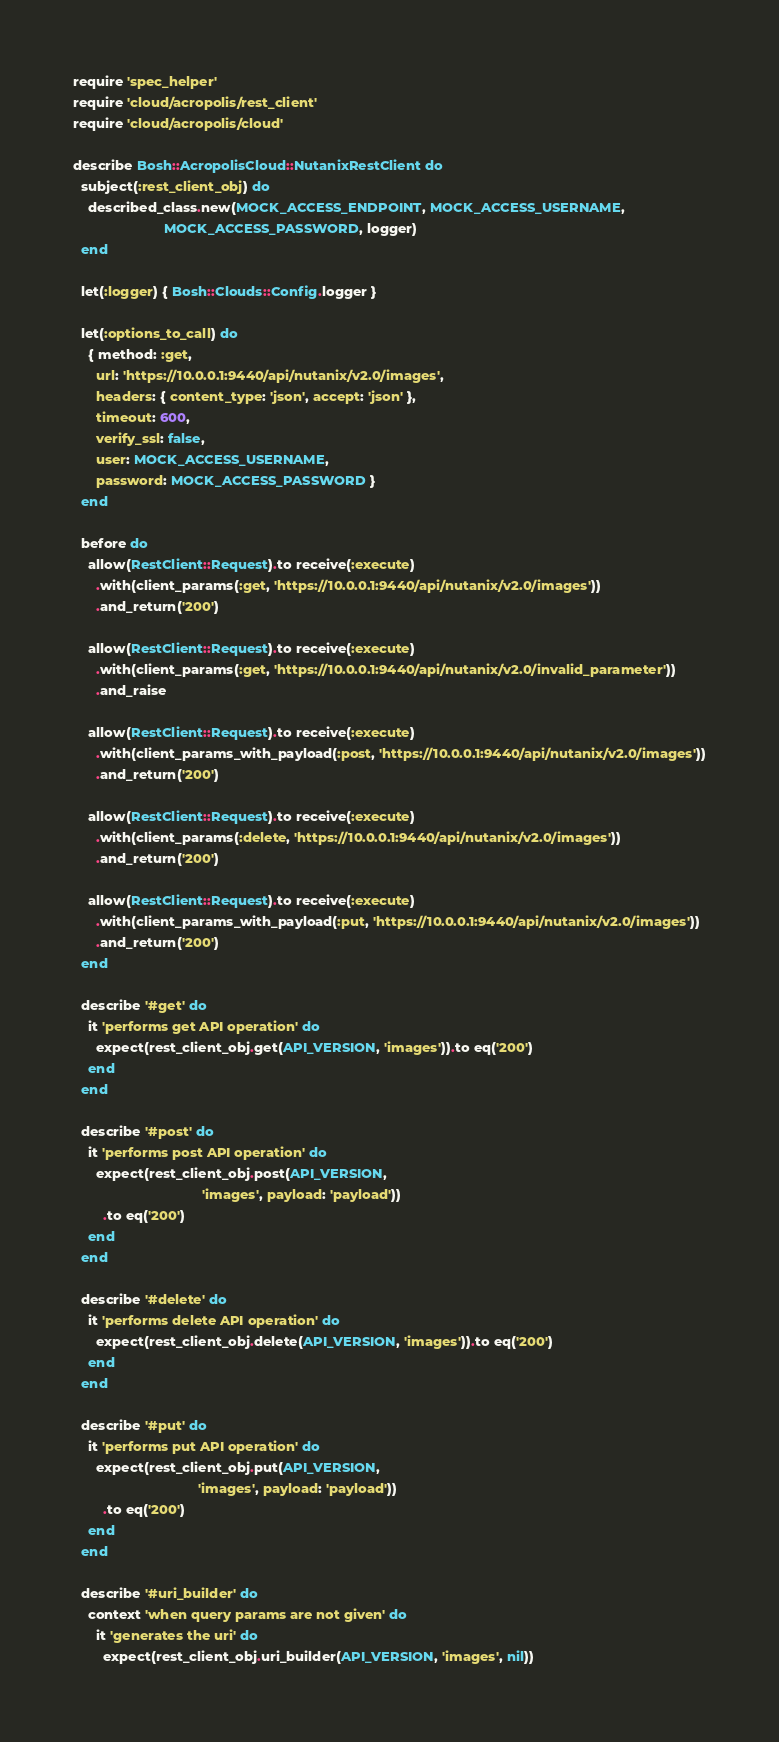<code> <loc_0><loc_0><loc_500><loc_500><_Ruby_>require 'spec_helper'
require 'cloud/acropolis/rest_client'
require 'cloud/acropolis/cloud'

describe Bosh::AcropolisCloud::NutanixRestClient do
  subject(:rest_client_obj) do
    described_class.new(MOCK_ACCESS_ENDPOINT, MOCK_ACCESS_USERNAME,
                        MOCK_ACCESS_PASSWORD, logger)
  end

  let(:logger) { Bosh::Clouds::Config.logger }

  let(:options_to_call) do
    { method: :get,
      url: 'https://10.0.0.1:9440/api/nutanix/v2.0/images',
      headers: { content_type: 'json', accept: 'json' },
      timeout: 600,
      verify_ssl: false,
      user: MOCK_ACCESS_USERNAME,
      password: MOCK_ACCESS_PASSWORD }
  end

  before do
    allow(RestClient::Request).to receive(:execute)
      .with(client_params(:get, 'https://10.0.0.1:9440/api/nutanix/v2.0/images'))
      .and_return('200')

    allow(RestClient::Request).to receive(:execute)
      .with(client_params(:get, 'https://10.0.0.1:9440/api/nutanix/v2.0/invalid_parameter'))
      .and_raise

    allow(RestClient::Request).to receive(:execute)
      .with(client_params_with_payload(:post, 'https://10.0.0.1:9440/api/nutanix/v2.0/images'))
      .and_return('200')

    allow(RestClient::Request).to receive(:execute)
      .with(client_params(:delete, 'https://10.0.0.1:9440/api/nutanix/v2.0/images'))
      .and_return('200')

    allow(RestClient::Request).to receive(:execute)
      .with(client_params_with_payload(:put, 'https://10.0.0.1:9440/api/nutanix/v2.0/images'))
      .and_return('200')
  end

  describe '#get' do
    it 'performs get API operation' do
      expect(rest_client_obj.get(API_VERSION, 'images')).to eq('200')
    end
  end

  describe '#post' do
    it 'performs post API operation' do
      expect(rest_client_obj.post(API_VERSION,
                                  'images', payload: 'payload'))
        .to eq('200')
    end
  end

  describe '#delete' do
    it 'performs delete API operation' do
      expect(rest_client_obj.delete(API_VERSION, 'images')).to eq('200')
    end
  end

  describe '#put' do
    it 'performs put API operation' do
      expect(rest_client_obj.put(API_VERSION,
                                 'images', payload: 'payload'))
        .to eq('200')
    end
  end

  describe '#uri_builder' do
    context 'when query params are not given' do
      it 'generates the uri' do
        expect(rest_client_obj.uri_builder(API_VERSION, 'images', nil))</code> 